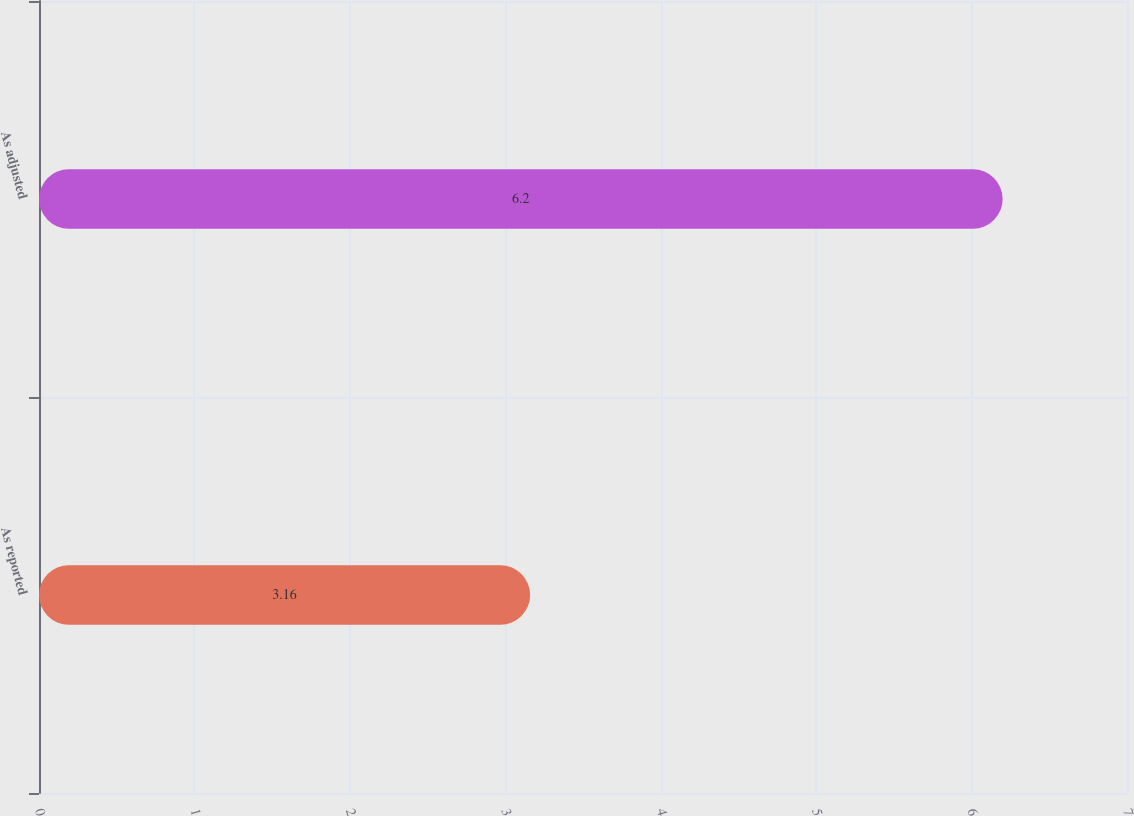Convert chart. <chart><loc_0><loc_0><loc_500><loc_500><bar_chart><fcel>As reported<fcel>As adjusted<nl><fcel>3.16<fcel>6.2<nl></chart> 